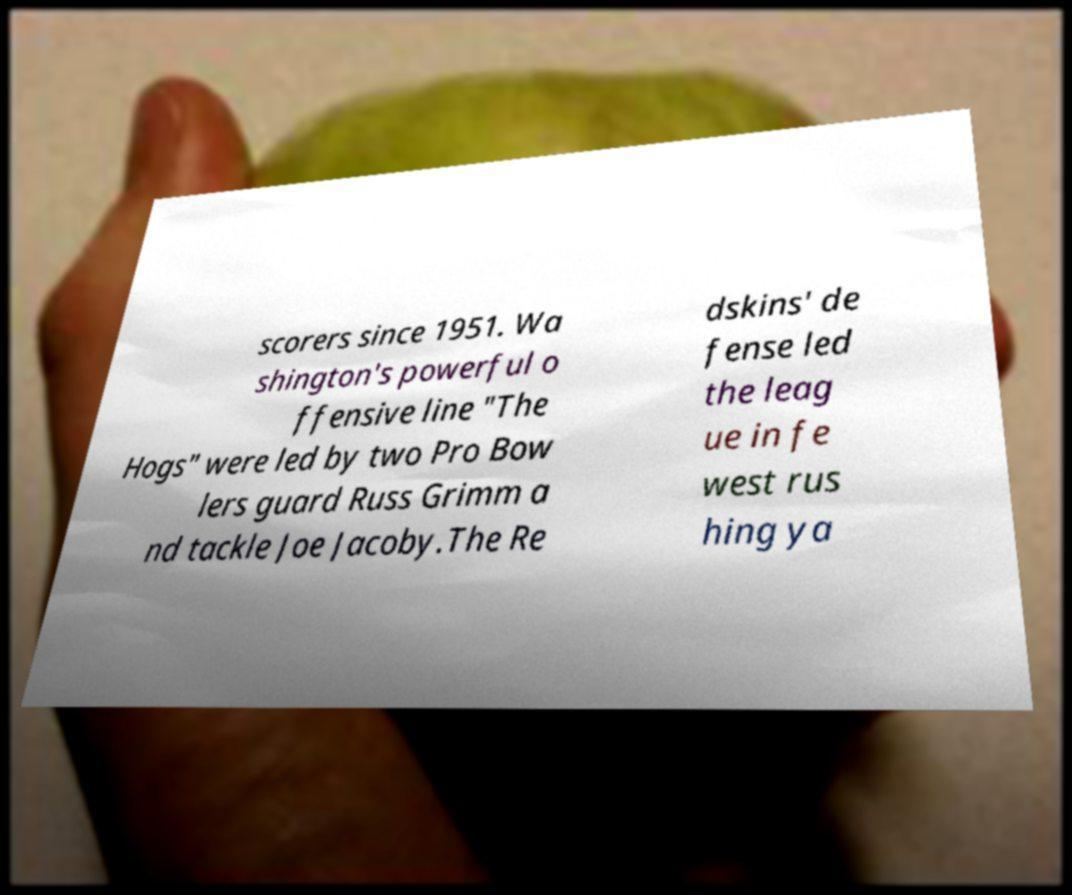For documentation purposes, I need the text within this image transcribed. Could you provide that? scorers since 1951. Wa shington's powerful o ffensive line "The Hogs" were led by two Pro Bow lers guard Russ Grimm a nd tackle Joe Jacoby.The Re dskins' de fense led the leag ue in fe west rus hing ya 